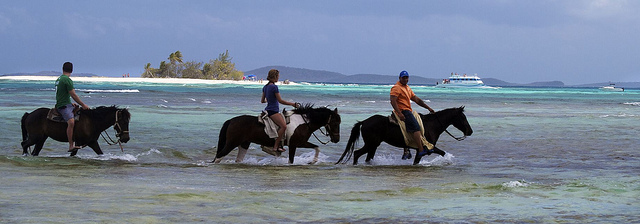How many horses are visible? There are three horses visible in the image, each being ridden by a person along the shore, with beautiful turquoise waters in the background and a boat visible on the horizon. 